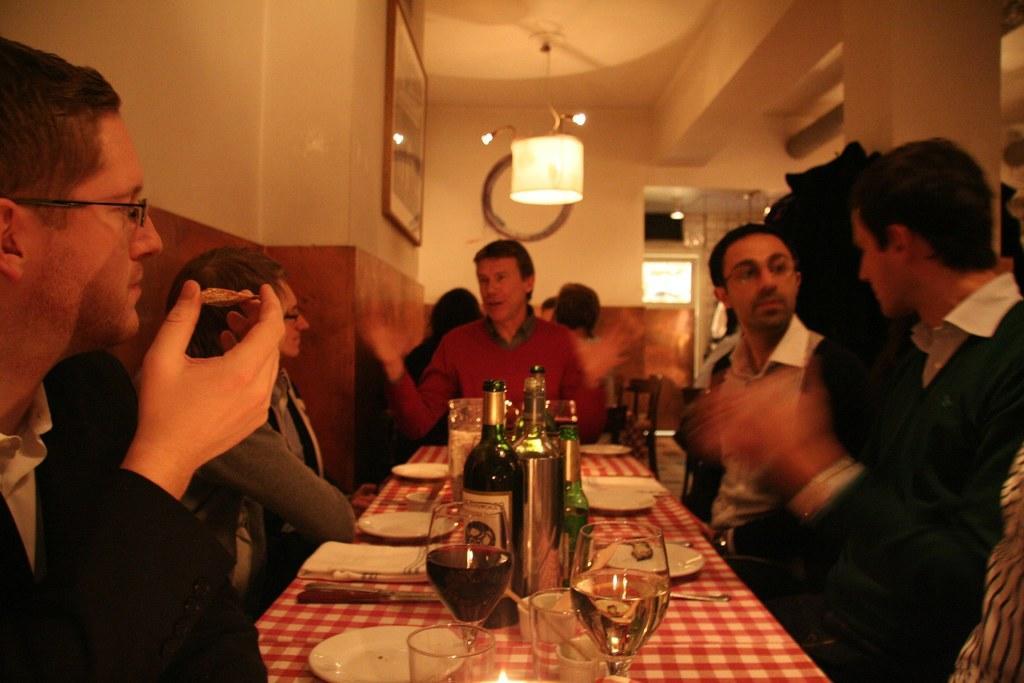Describe this image in one or two sentences. In this image two persons are sitting at the right side and two persons are sitting at the left side and few persons are sitting at the middle of image. There is a table on which glasses , plates, knife, napkins, bottles are placed. There is a light hanging from the roof. To the wall there is a picture frame. 